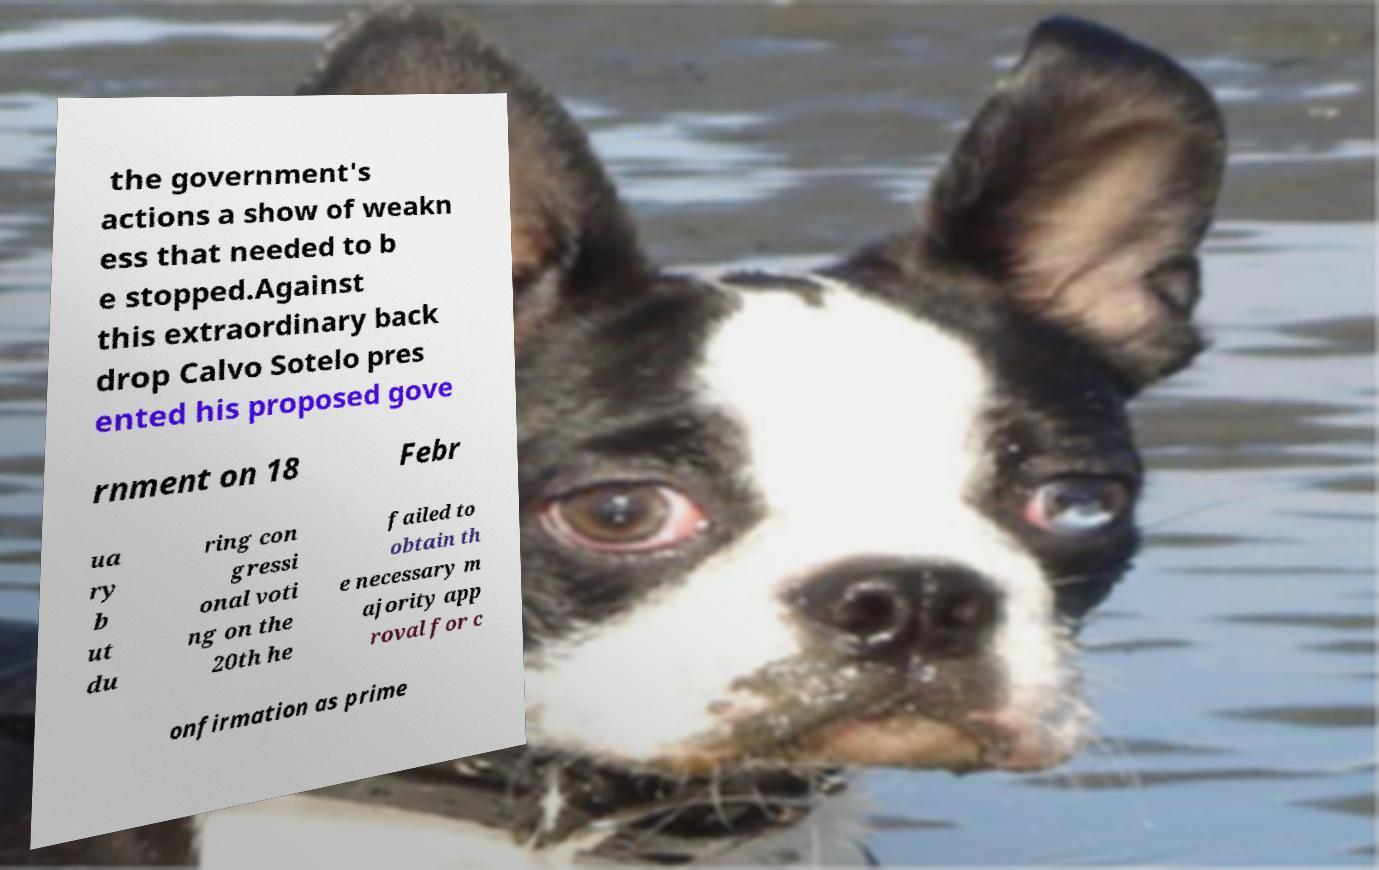Could you assist in decoding the text presented in this image and type it out clearly? the government's actions a show of weakn ess that needed to b e stopped.Against this extraordinary back drop Calvo Sotelo pres ented his proposed gove rnment on 18 Febr ua ry b ut du ring con gressi onal voti ng on the 20th he failed to obtain th e necessary m ajority app roval for c onfirmation as prime 